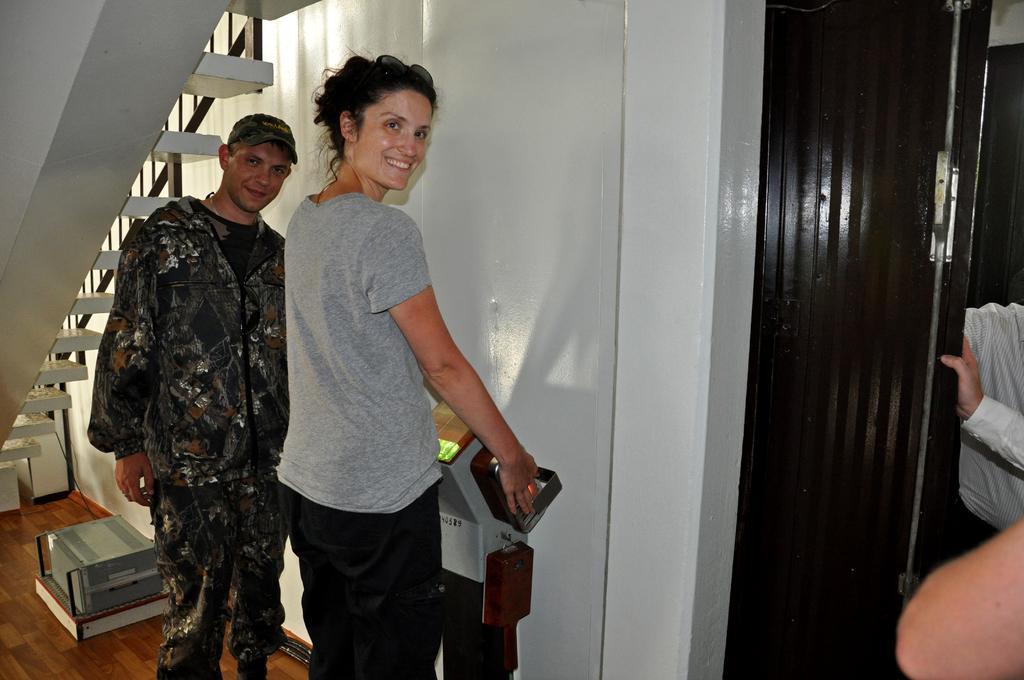In one or two sentences, can you explain what this image depicts? In this picture we can see a man and a woman standing and smiling, on the left side there are stars, we can see a wall in the background, we can see another person on the right side. 